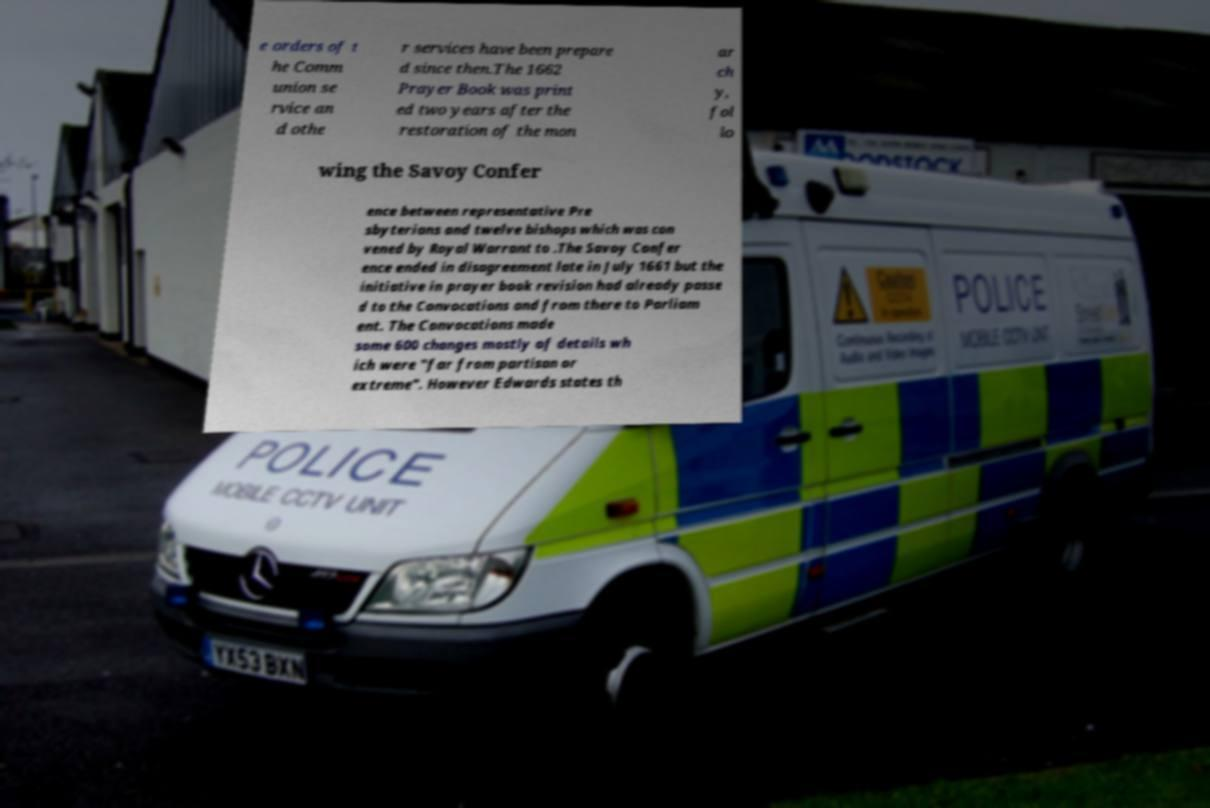Please read and relay the text visible in this image. What does it say? e orders of t he Comm union se rvice an d othe r services have been prepare d since then.The 1662 Prayer Book was print ed two years after the restoration of the mon ar ch y, fol lo wing the Savoy Confer ence between representative Pre sbyterians and twelve bishops which was con vened by Royal Warrant to .The Savoy Confer ence ended in disagreement late in July 1661 but the initiative in prayer book revision had already passe d to the Convocations and from there to Parliam ent. The Convocations made some 600 changes mostly of details wh ich were "far from partisan or extreme". However Edwards states th 